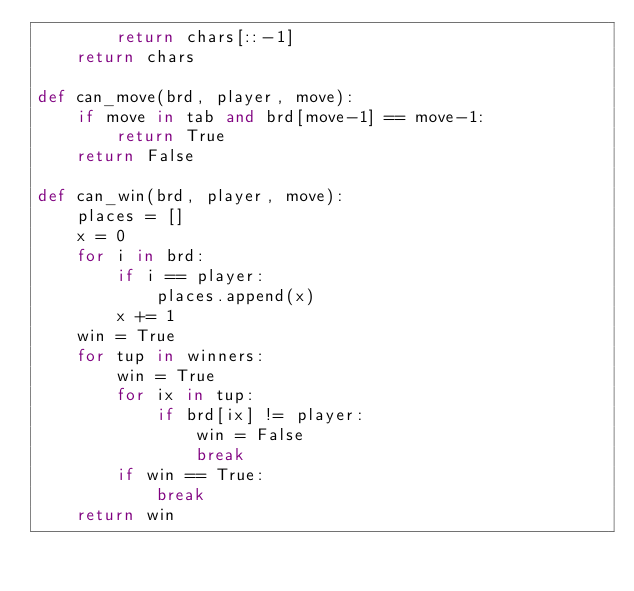Convert code to text. <code><loc_0><loc_0><loc_500><loc_500><_Python_>        return chars[::-1]
    return chars 

def can_move(brd, player, move):
    if move in tab and brd[move-1] == move-1:
        return True
    return False

def can_win(brd, player, move):
    places = []
    x = 0
    for i in brd:
        if i == player:
            places.append(x)
        x += 1
    win = True
    for tup in winners:
        win = True 
        for ix in tup:
            if brd[ix] != player:
                win = False
                break
        if win == True:
            break
    return win 
</code> 